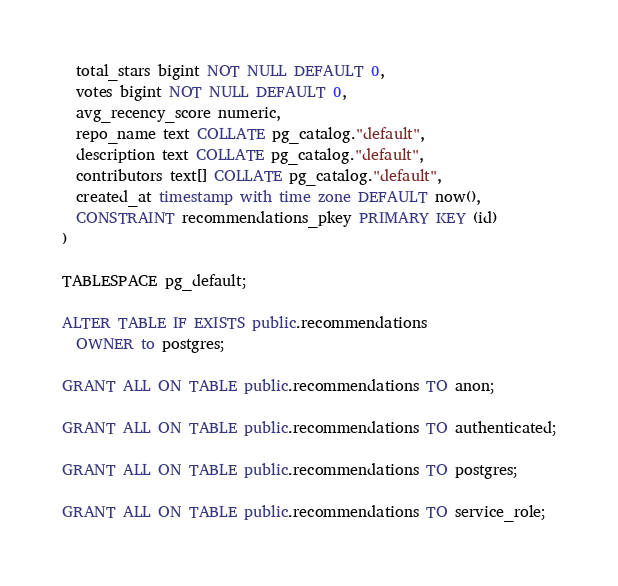Convert code to text. <code><loc_0><loc_0><loc_500><loc_500><_SQL_>  total_stars bigint NOT NULL DEFAULT 0,
  votes bigint NOT NULL DEFAULT 0,
  avg_recency_score numeric,
  repo_name text COLLATE pg_catalog."default",
  description text COLLATE pg_catalog."default",
  contributors text[] COLLATE pg_catalog."default",
  created_at timestamp with time zone DEFAULT now(),
  CONSTRAINT recommendations_pkey PRIMARY KEY (id)
)

TABLESPACE pg_default;

ALTER TABLE IF EXISTS public.recommendations
  OWNER to postgres;

GRANT ALL ON TABLE public.recommendations TO anon;

GRANT ALL ON TABLE public.recommendations TO authenticated;

GRANT ALL ON TABLE public.recommendations TO postgres;

GRANT ALL ON TABLE public.recommendations TO service_role;
</code> 